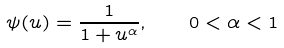Convert formula to latex. <formula><loc_0><loc_0><loc_500><loc_500>\psi ( u ) = \frac { 1 } { 1 + u ^ { \alpha } } , \quad 0 < \alpha < 1</formula> 